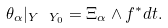<formula> <loc_0><loc_0><loc_500><loc_500>\theta _ { \alpha } | _ { Y \ Y _ { 0 } } = \Xi _ { \alpha } \wedge f ^ { * } d t .</formula> 